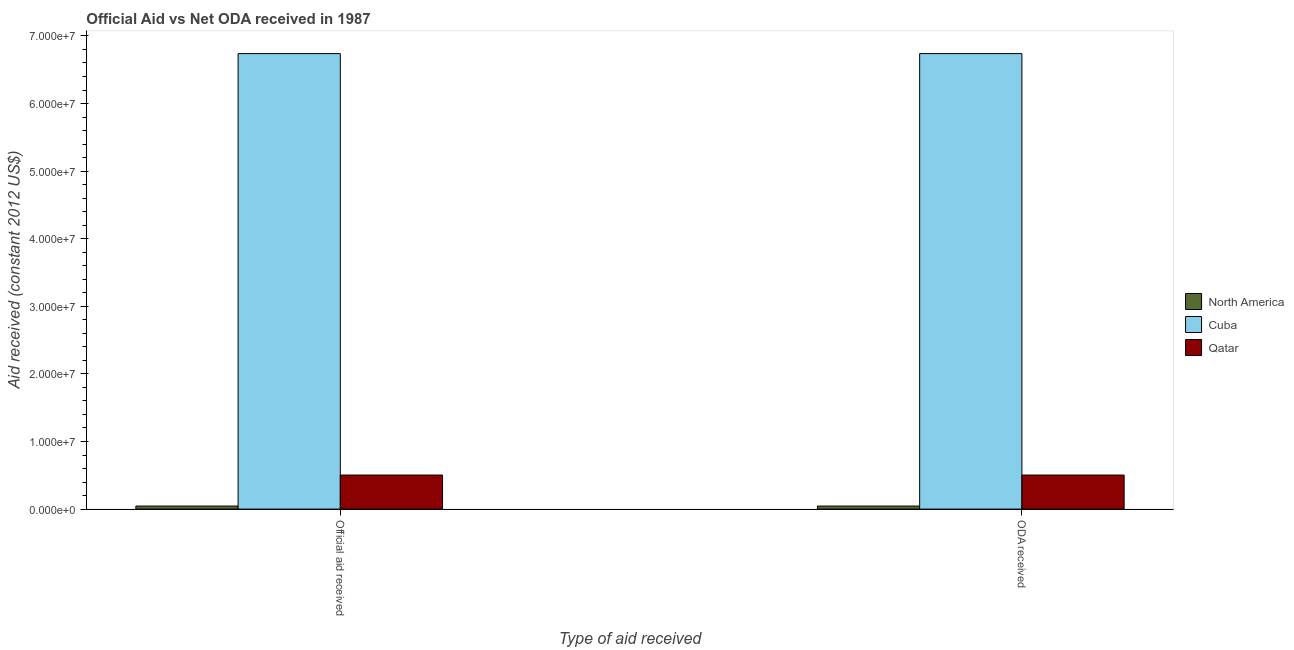How many groups of bars are there?
Your answer should be compact. 2. How many bars are there on the 2nd tick from the right?
Offer a terse response. 3. What is the label of the 2nd group of bars from the left?
Keep it short and to the point. ODA received. What is the oda received in North America?
Ensure brevity in your answer.  4.50e+05. Across all countries, what is the maximum oda received?
Ensure brevity in your answer.  6.74e+07. Across all countries, what is the minimum oda received?
Offer a very short reply. 4.50e+05. In which country was the oda received maximum?
Your answer should be very brief. Cuba. In which country was the oda received minimum?
Provide a short and direct response. North America. What is the total official aid received in the graph?
Provide a short and direct response. 7.29e+07. What is the difference between the official aid received in North America and that in Cuba?
Your response must be concise. -6.69e+07. What is the difference between the oda received in Cuba and the official aid received in North America?
Your response must be concise. 6.69e+07. What is the average official aid received per country?
Give a very brief answer. 2.43e+07. What is the difference between the oda received and official aid received in North America?
Provide a short and direct response. 0. What is the ratio of the official aid received in Cuba to that in North America?
Give a very brief answer. 149.76. What does the 1st bar from the right in ODA received represents?
Ensure brevity in your answer.  Qatar. How many bars are there?
Keep it short and to the point. 6. How many countries are there in the graph?
Ensure brevity in your answer.  3. Does the graph contain any zero values?
Provide a succinct answer. No. Where does the legend appear in the graph?
Your answer should be compact. Center right. How many legend labels are there?
Make the answer very short. 3. What is the title of the graph?
Your answer should be very brief. Official Aid vs Net ODA received in 1987 . Does "Ukraine" appear as one of the legend labels in the graph?
Offer a very short reply. No. What is the label or title of the X-axis?
Offer a very short reply. Type of aid received. What is the label or title of the Y-axis?
Keep it short and to the point. Aid received (constant 2012 US$). What is the Aid received (constant 2012 US$) in Cuba in Official aid received?
Keep it short and to the point. 6.74e+07. What is the Aid received (constant 2012 US$) in Qatar in Official aid received?
Give a very brief answer. 5.04e+06. What is the Aid received (constant 2012 US$) of North America in ODA received?
Provide a short and direct response. 4.50e+05. What is the Aid received (constant 2012 US$) in Cuba in ODA received?
Ensure brevity in your answer.  6.74e+07. What is the Aid received (constant 2012 US$) in Qatar in ODA received?
Your answer should be very brief. 5.04e+06. Across all Type of aid received, what is the maximum Aid received (constant 2012 US$) of North America?
Make the answer very short. 4.50e+05. Across all Type of aid received, what is the maximum Aid received (constant 2012 US$) of Cuba?
Ensure brevity in your answer.  6.74e+07. Across all Type of aid received, what is the maximum Aid received (constant 2012 US$) of Qatar?
Offer a terse response. 5.04e+06. Across all Type of aid received, what is the minimum Aid received (constant 2012 US$) in Cuba?
Keep it short and to the point. 6.74e+07. Across all Type of aid received, what is the minimum Aid received (constant 2012 US$) in Qatar?
Make the answer very short. 5.04e+06. What is the total Aid received (constant 2012 US$) of Cuba in the graph?
Ensure brevity in your answer.  1.35e+08. What is the total Aid received (constant 2012 US$) in Qatar in the graph?
Your answer should be very brief. 1.01e+07. What is the difference between the Aid received (constant 2012 US$) of Cuba in Official aid received and that in ODA received?
Ensure brevity in your answer.  0. What is the difference between the Aid received (constant 2012 US$) of Qatar in Official aid received and that in ODA received?
Ensure brevity in your answer.  0. What is the difference between the Aid received (constant 2012 US$) in North America in Official aid received and the Aid received (constant 2012 US$) in Cuba in ODA received?
Keep it short and to the point. -6.69e+07. What is the difference between the Aid received (constant 2012 US$) of North America in Official aid received and the Aid received (constant 2012 US$) of Qatar in ODA received?
Your answer should be very brief. -4.59e+06. What is the difference between the Aid received (constant 2012 US$) of Cuba in Official aid received and the Aid received (constant 2012 US$) of Qatar in ODA received?
Provide a short and direct response. 6.24e+07. What is the average Aid received (constant 2012 US$) in Cuba per Type of aid received?
Provide a short and direct response. 6.74e+07. What is the average Aid received (constant 2012 US$) of Qatar per Type of aid received?
Your response must be concise. 5.04e+06. What is the difference between the Aid received (constant 2012 US$) of North America and Aid received (constant 2012 US$) of Cuba in Official aid received?
Make the answer very short. -6.69e+07. What is the difference between the Aid received (constant 2012 US$) of North America and Aid received (constant 2012 US$) of Qatar in Official aid received?
Your response must be concise. -4.59e+06. What is the difference between the Aid received (constant 2012 US$) of Cuba and Aid received (constant 2012 US$) of Qatar in Official aid received?
Provide a short and direct response. 6.24e+07. What is the difference between the Aid received (constant 2012 US$) in North America and Aid received (constant 2012 US$) in Cuba in ODA received?
Your response must be concise. -6.69e+07. What is the difference between the Aid received (constant 2012 US$) in North America and Aid received (constant 2012 US$) in Qatar in ODA received?
Make the answer very short. -4.59e+06. What is the difference between the Aid received (constant 2012 US$) in Cuba and Aid received (constant 2012 US$) in Qatar in ODA received?
Your response must be concise. 6.24e+07. What is the difference between the highest and the second highest Aid received (constant 2012 US$) of North America?
Offer a terse response. 0. What is the difference between the highest and the second highest Aid received (constant 2012 US$) of Qatar?
Offer a terse response. 0. What is the difference between the highest and the lowest Aid received (constant 2012 US$) in Qatar?
Your response must be concise. 0. 